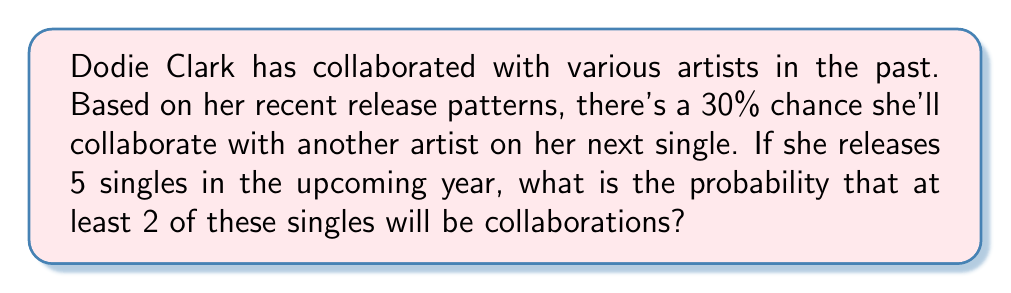Can you answer this question? To solve this problem, we can use the binomial probability distribution. Let's break it down step-by-step:

1) Let X be the random variable representing the number of collaborations in 5 singles.

2) We know that:
   - n (number of trials) = 5
   - p (probability of success on each trial) = 0.30
   - We want P(X ≥ 2)

3) We can calculate this as: P(X ≥ 2) = 1 - P(X < 2) = 1 - [P(X = 0) + P(X = 1)]

4) The probability mass function for a binomial distribution is:

   $$ P(X = k) = \binom{n}{k} p^k (1-p)^{n-k} $$

5) Let's calculate P(X = 0) and P(X = 1):

   $$ P(X = 0) = \binom{5}{0} (0.30)^0 (0.70)^5 = 1 \cdot 1 \cdot 0.16807 = 0.16807 $$

   $$ P(X = 1) = \binom{5}{1} (0.30)^1 (0.70)^4 = 5 \cdot 0.30 \cdot 0.2401 = 0.36015 $$

6) Now we can calculate P(X ≥ 2):

   $$ P(X ≥ 2) = 1 - [P(X = 0) + P(X = 1)] = 1 - (0.16807 + 0.36015) = 1 - 0.52822 = 0.47178 $$

Therefore, the probability that at least 2 out of 5 singles will be collaborations is approximately 0.47178 or 47.18%.
Answer: 0.47178 or 47.18% 